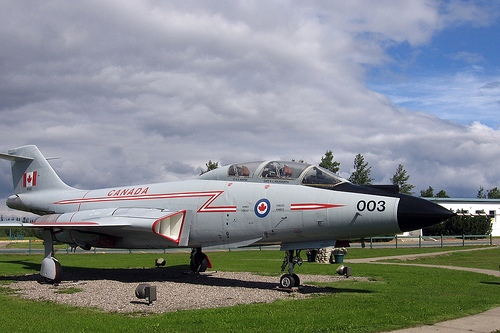<image>
Is the plane next to the tree? No. The plane is not positioned next to the tree. They are located in different areas of the scene. Where is the jet in relation to the grass? Is it above the grass? Yes. The jet is positioned above the grass in the vertical space, higher up in the scene. 